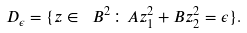Convert formula to latex. <formula><loc_0><loc_0><loc_500><loc_500>D _ { \epsilon } = \{ z \in \ B ^ { 2 } \colon A z _ { 1 } ^ { 2 } + B z _ { 2 } ^ { 2 } = \epsilon \} .</formula> 